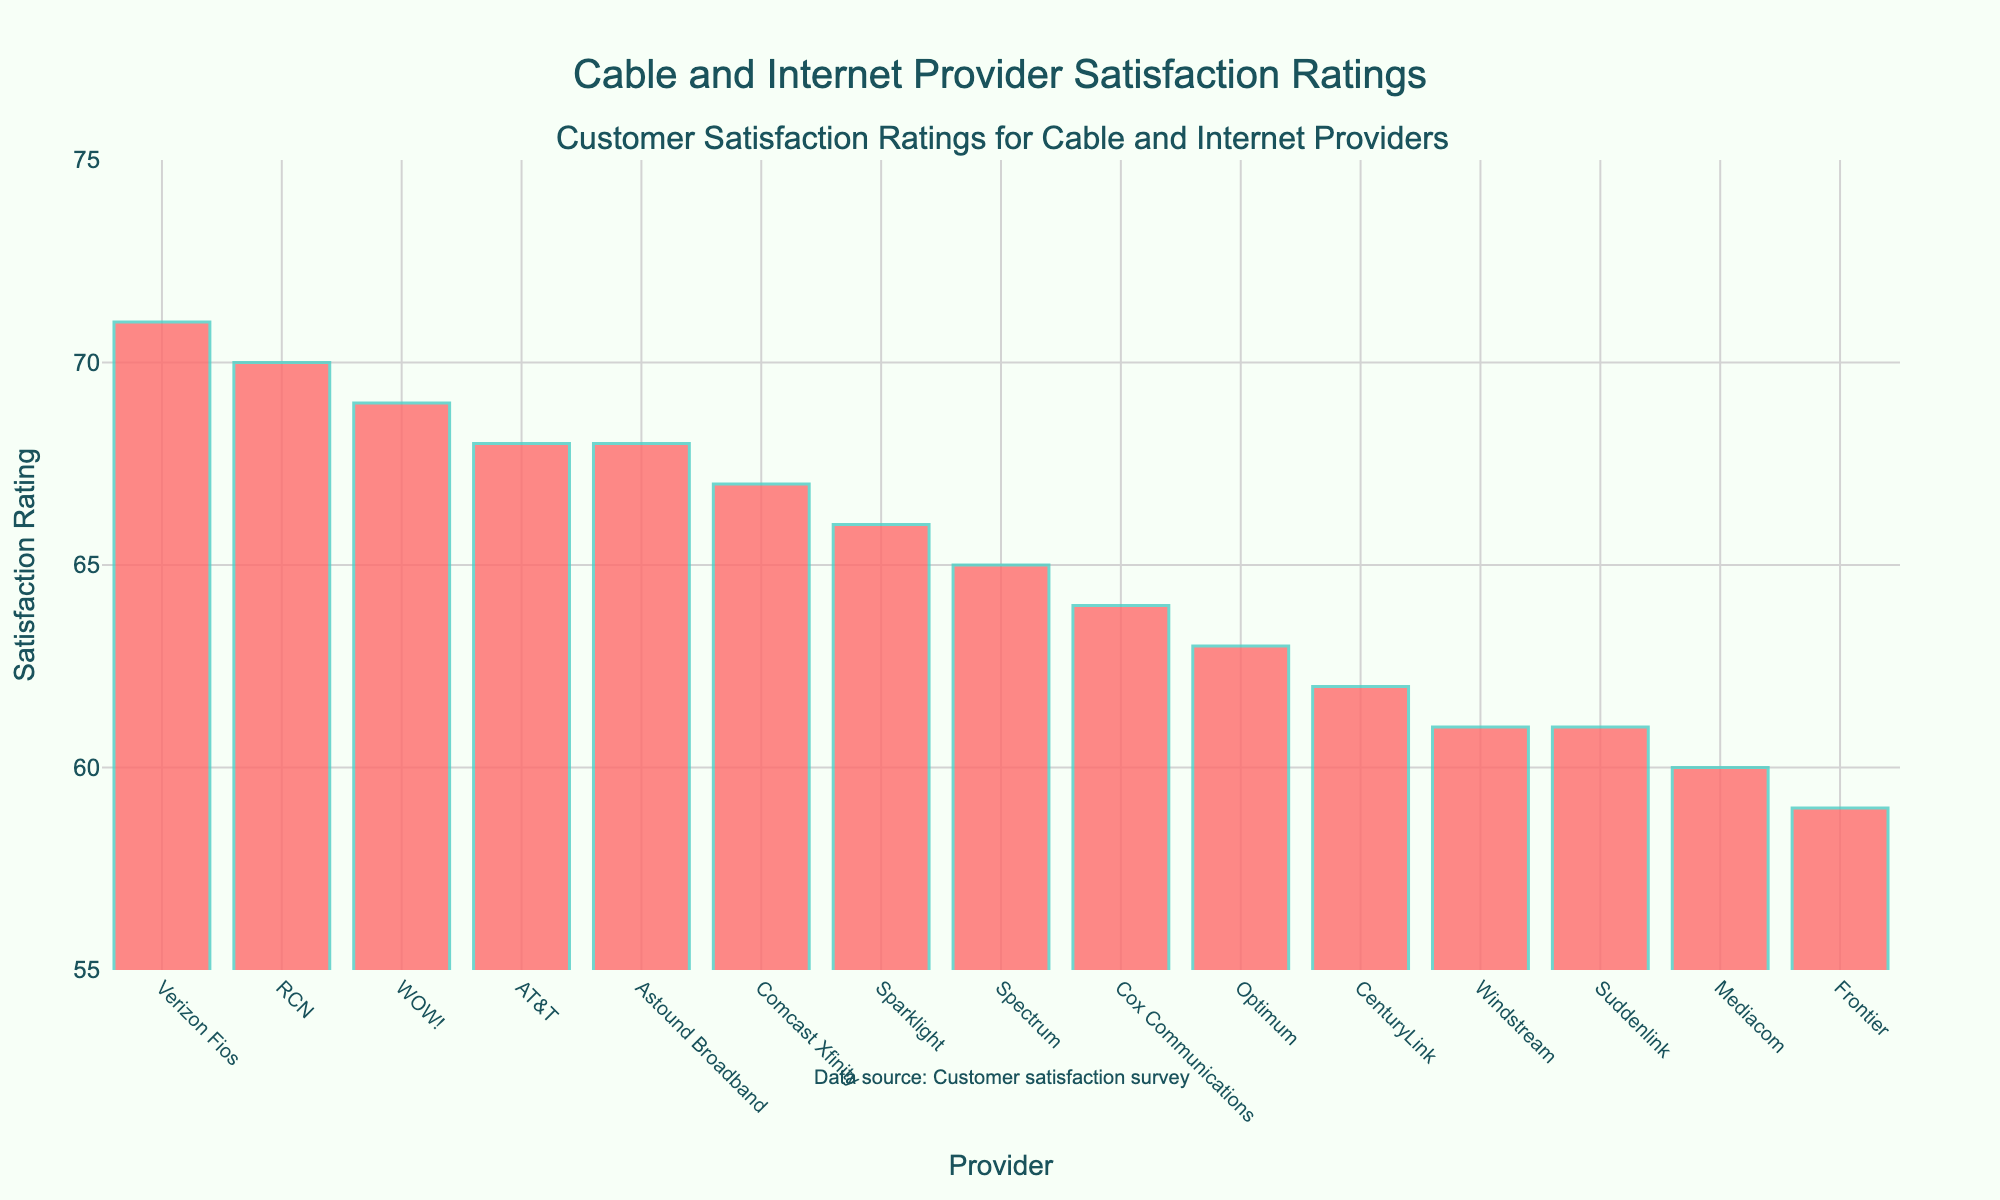Which provider has the highest satisfaction rating? Looking at the height of the bars in the chart, the provider with the highest satisfaction rating can be identified. The tallest bar corresponds to Verizon Fios.
Answer: Verizon Fios Which provider has the lowest satisfaction rating? The provider with the lowest satisfaction rating can be found by identifying the shortest bar in the chart. The shortest bar corresponds to Frontier.
Answer: Frontier What is the average satisfaction rating of Comcast Xfinity and AT&T? The satisfaction ratings for Comcast Xfinity and AT&T are 67 and 68, respectively. Adding these ratings together gives 135, and dividing by 2 gives the average: 135 / 2 = 67.5.
Answer: 67.5 How many points higher is RCN's satisfaction rating compared to Comcast Xfinity? RCN's satisfaction rating is 70, and Comcast Xfinity's rating is 67. Subtracting Comcast Xfinity's rating from RCN's rating gives: 70 - 67 = 3.
Answer: 3 Which providers have satisfaction ratings above 68? The satisfaction ratings above 68 in the chart are for Verizon Fios (71), RCN (70), and WOW! (69). Thus, the providers are Verizon Fios, RCN, and WOW!.
Answer: Verizon Fios, RCN, WOW! What is the difference in satisfaction ratings between the highest-ranked and lowest-ranked providers? The highest satisfaction rating is 71 (Verizon Fios) and the lowest is 59 (Frontier). Subtracting the lowest from the highest gives: 71 - 59 = 12.
Answer: 12 List the providers with satisfaction ratings between 64 and 66 inclusive. The bars corresponding to the satisfaction ratings between 64 and 66 are identified. These ratings belong to Cox Communications (64), Optimum (63), and Sparklight (66).
Answer: Cox Communications, Optimum, Sparklight 